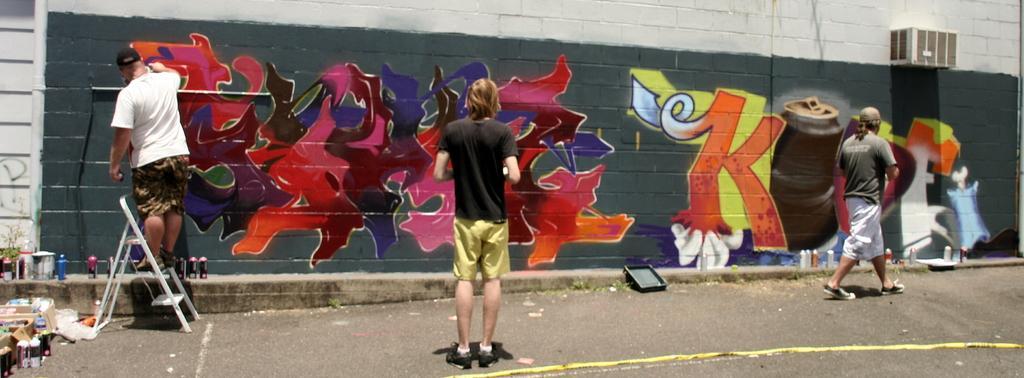How would you summarize this image in a sentence or two? This picture is clicked outside. In the center there is a person standing on the ground. On the right we can see a person walking on the ground and there are some objects placed on the ground. On the left there is a man standing on a ladder and doing the art of graffiti on the wall. 